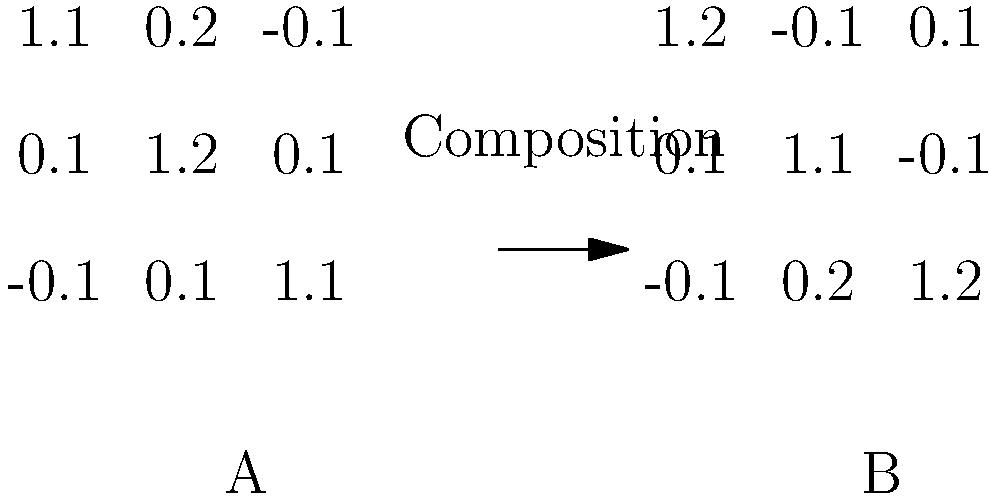In color grading for film post-production, we often use 3x3 matrices to adjust the color balance. Given two color grading matrices A and B as shown in the image, what property of group theory is demonstrated when we compose these matrices (i.e., apply one after the other)? How does this relate to the flexibility of color grading in post-production? To answer this question, let's follow these steps:

1. Recall that matrix multiplication is not commutative in general. This means $AB \neq BA$ for most matrices A and B.

2. In the context of color grading:
   - Matrix A represents one color adjustment
   - Matrix B represents another color adjustment

3. When we compose these matrices (multiply them), we are essentially applying one color adjustment after another.

4. The non-commutativity of matrix multiplication means that the order of applying these color adjustments matters. That is, applying A then B will generally give a different result than applying B then A.

5. This property is related to the group theory concept of non-abelian groups. A group is non-abelian if its operation (in this case, matrix multiplication) is not commutative.

6. In terms of post-production flexibility:
   - This non-commutativity allows for a wide range of color grading possibilities
   - It gives colorists the ability to fine-tune their adjustments by carefully considering the order of operations
   - It also means that colorists need to be aware of the order in which they apply adjustments, as changing this order can significantly affect the final result

7. This property is crucial in color grading as it allows for complex and nuanced adjustments that wouldn't be possible if the order of operations didn't matter.
Answer: Non-commutativity (non-abelian group property) 